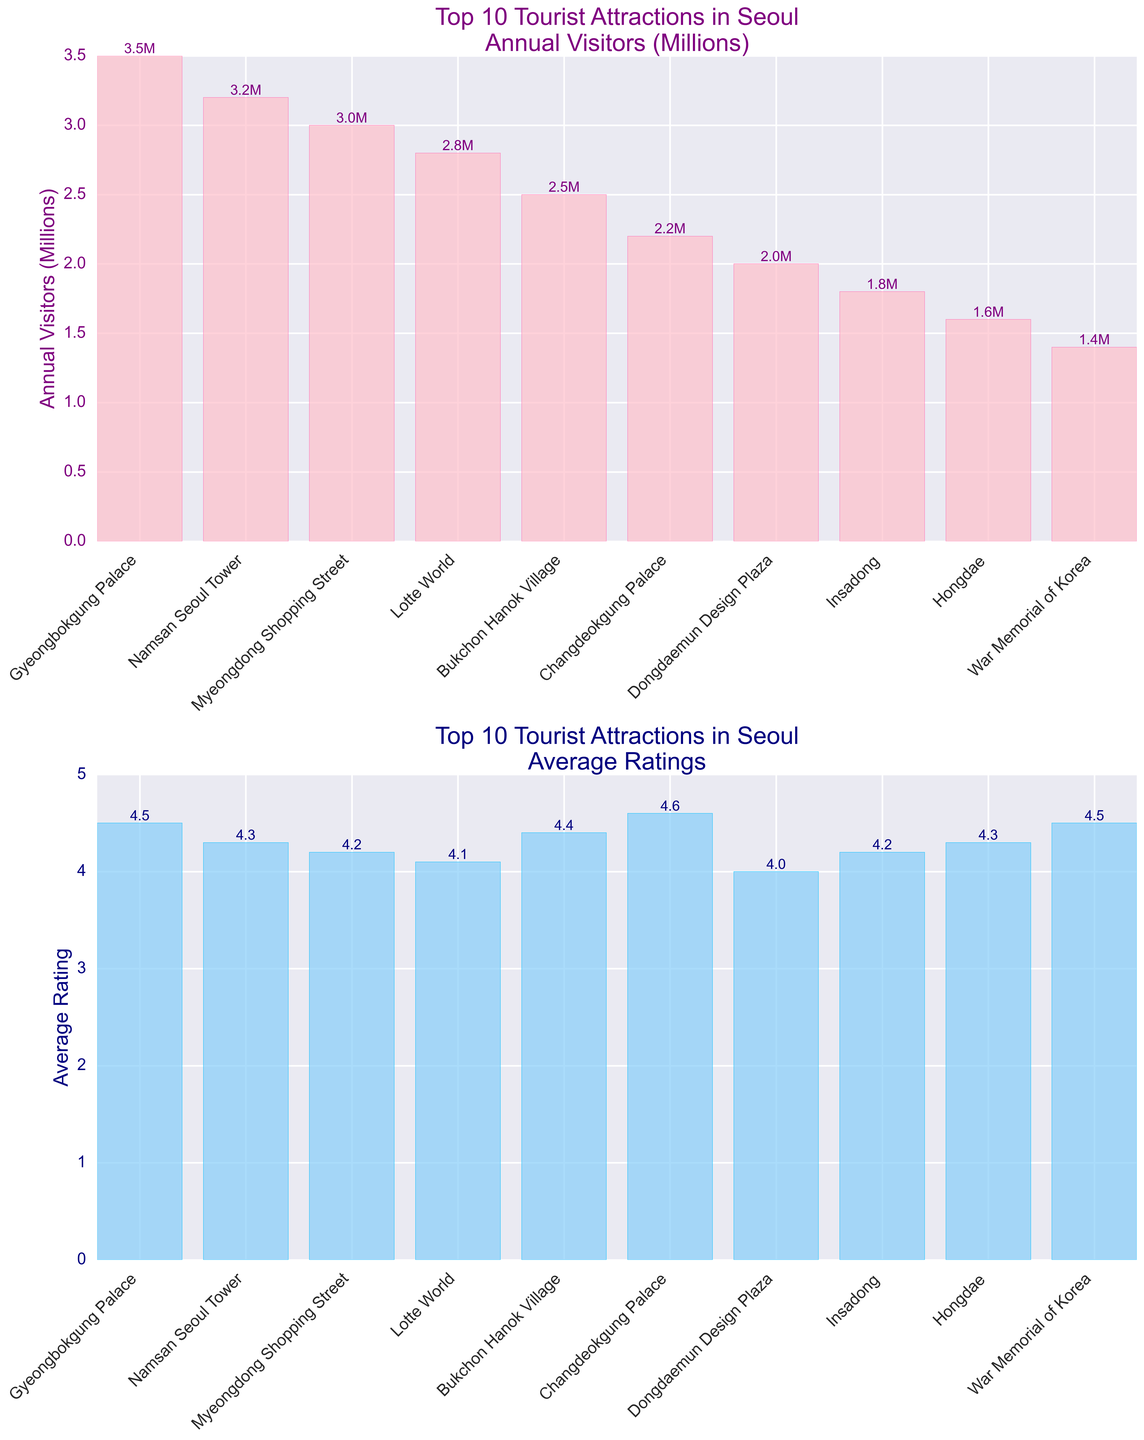What's the total number of annual visitors for the top 3 attractions combined? The top 3 attractions based on annual visitors are Gyeongbokgung Palace, Namsan Seoul Tower, and Myeongdong Shopping Street with 3.5 million, 3.2 million, and 3.0 million visitors respectively. The total is 3.5 + 3.2 + 3.0 = 9.7 million.
Answer: 9.7 million Which attraction has the highest average rating among the top 10 attractions? Among the top 10 attractions, Changdeokgung Palace has the highest average rating of 4.6 as indicated by the tallest bar in the average rating subplot.
Answer: Changdeokgung Palace How much higher is the average rating of the War Memorial of Korea compared to Namdaemun Market? The War Memorial of Korea has an average rating of 4.5 and Namdaemun Market has an average rating of 3.9. The difference is 4.5 - 3.9 = 0.6.
Answer: 0.6 Considering the top 5 attractions by annual visitors, what is their average rating? The top 5 attractions by annual visitors are Gyeongbokgung Palace, Namsan Seoul Tower, Myeongdong Shopping Street, Lotte World, and Bukchon Hanok Village. Their ratings are 4.5, 4.3, 4.2, 4.1, and 4.4. The average rating is (4.5+4.3+4.2+4.1+4.4)/5 = 21.5/5 = 4.3.
Answer: 4.3 Which attraction among the top 10 has the lowest number of annual visitors, and how many visitors does it have? Among the top 10, the War Memorial of Korea has the lowest number of annual visitors with 1.4 million as indicated by the shortest bar in the annual visitors subplot.
Answer: War Memorial of Korea, 1.4 million What is the total sum of average ratings for the top 10 attractions? The average ratings for the top 10 attractions are 4.5, 4.3, 4.2, 4.1, 4.4, 4.6, 4.0, 4.2, 4.3, and 4.5. The total sum is 4.5 + 4.3 + 4.2 + 4.1 + 4.4 + 4.6 + 4.0 + 4.2 + 4.3 + 4.5 = 43.1.
Answer: 43.1 How does the number of annual visitors for Namsan Seoul Tower compare to that of Bukchon Hanok Village? Namsan Seoul Tower has 3.2 million annual visitors whereas Bukchon Hanok Village has 2.5 million visitors. Namsan Seoul Tower attracts more visitors than Bukchon Hanok Village.
Answer: Namsan Seoul Tower attracts more What is the difference in average rating between the highest-rated attraction and the lowest-rated attraction among the top 10? The highest-rated attraction is Changdeokgung Palace with an average rating of 4.6, and the lowest-rated attraction is Dongdaemun Design Plaza with an average rating of 4.0. The difference is 4.6 - 4.0 = 0.6.
Answer: 0.6 What is the visual difference in the bar heights for Gyeongbokgung Palace in both subplots? In the annual visitors subplot, the bar for Gyeongbokgung Palace is the tallest, representing the highest number of visitors (3.5 million). In the average rating subplot, the bar is shorter, but still significantly high, representing a rating of 4.5. The visual difference is the relative height change between the highest number of visitors and a strong, but not the highest, average rating.
Answer: Taller in visitors plot, slightly shorter in ratings plot 